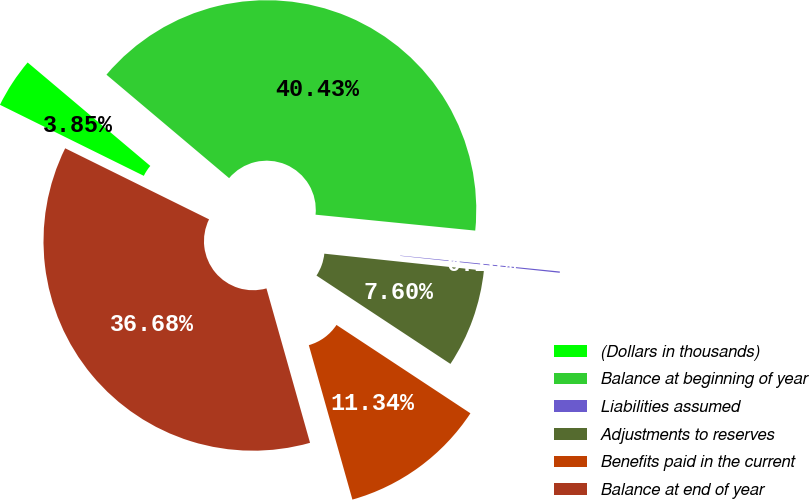<chart> <loc_0><loc_0><loc_500><loc_500><pie_chart><fcel>(Dollars in thousands)<fcel>Balance at beginning of year<fcel>Liabilities assumed<fcel>Adjustments to reserves<fcel>Benefits paid in the current<fcel>Balance at end of year<nl><fcel>3.85%<fcel>40.43%<fcel>0.1%<fcel>7.6%<fcel>11.34%<fcel>36.68%<nl></chart> 